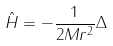Convert formula to latex. <formula><loc_0><loc_0><loc_500><loc_500>\hat { H } = - \frac { 1 } { 2 M r ^ { 2 } } \Delta</formula> 